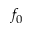Convert formula to latex. <formula><loc_0><loc_0><loc_500><loc_500>f _ { 0 }</formula> 